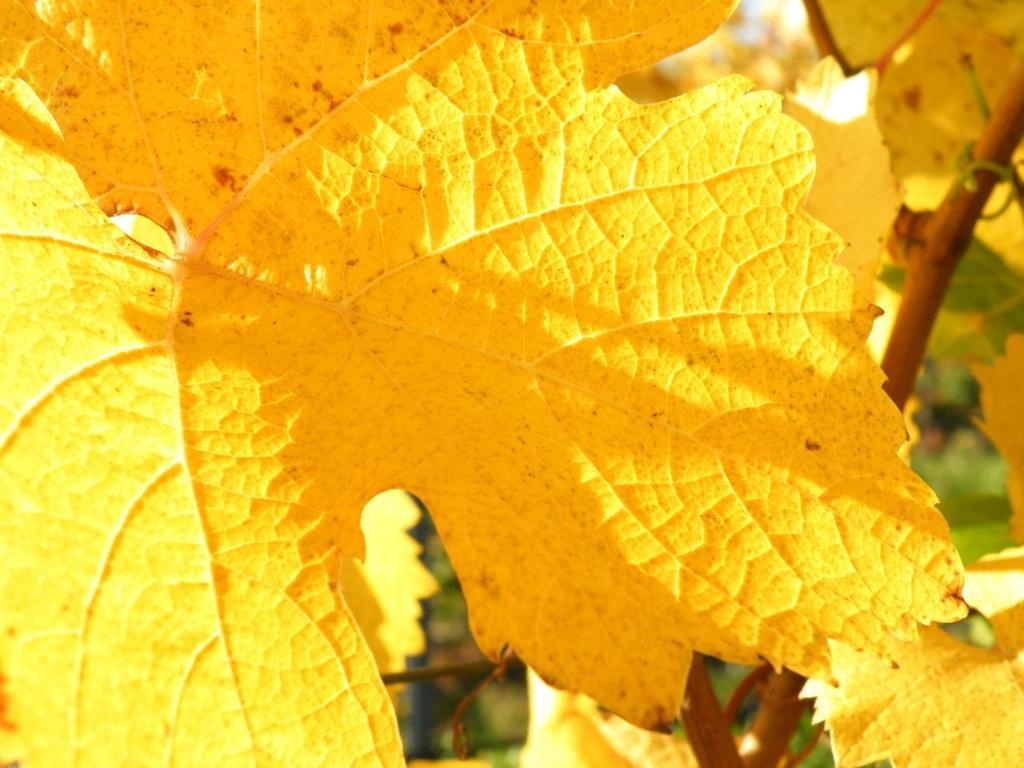What is the main subject in the image? There is a tree in the image. What is unique about the tree's appearance? The tree has yellow color leaves. What can be seen in the background of the image? In the background, there are green color leaves. What type of transport can be seen in the image? There is no transport visible in the image; it only features a tree with yellow leaves and a background of green leaves. Is there a scarf hanging from the tree in the image? No, there is no scarf present in the image. 